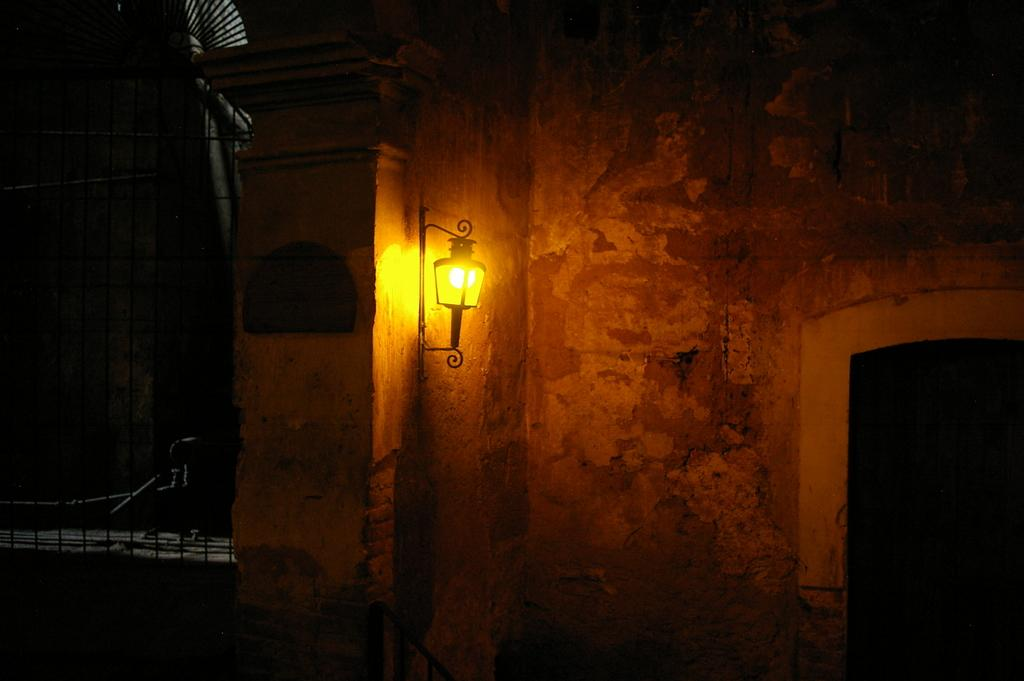What is present on one side of the image? There is a wall in the image. What can be seen on the wall? There is a light in the image. How would you describe the lighting conditions on the right side of the image? The right side of the image is completely dark. How would you describe the lighting conditions on the left side of the image? The left side of the image is also completely dark. What type of arithmetic problem is being solved on the roof in the image? There is no roof or arithmetic problem present in the image. How many clocks can be seen on the wall in the image? There are no clocks visible in the image; only a light is present on the wall. 